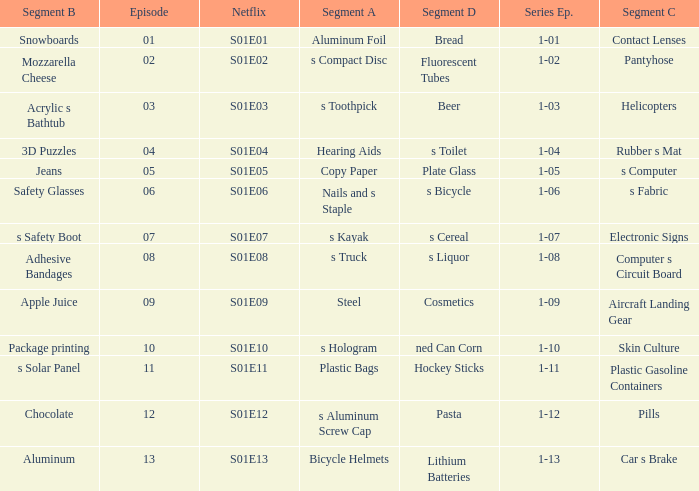What is the Netflix number having a segment of C of pills? S01E12. 